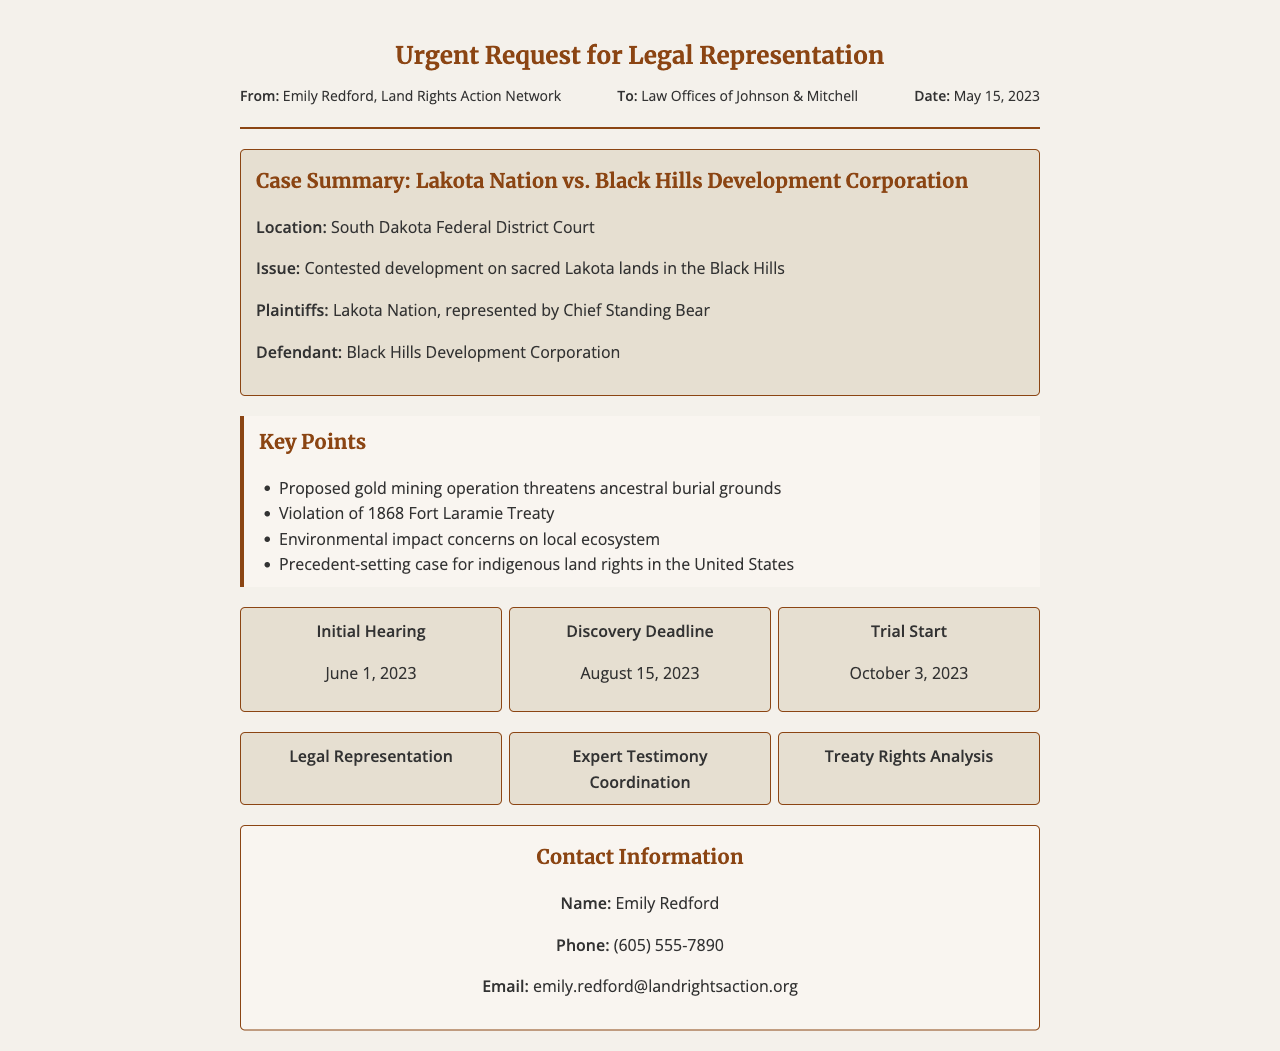what is the case title? The case title is mentioned prominently in the case summary section of the document.
Answer: Lakota Nation vs. Black Hills Development Corporation who is the plaintiff in the case? The plaintiffs of the case are identified in the case summary section, highlighting who is bringing the case to court.
Answer: Lakota Nation what date is the trial scheduled to start? The trial start date is included in the court dates section, providing a specific timeline for the proceedings.
Answer: October 3, 2023 what is the main issue being contested in the case? The main issue is provided in the case summary, explaining the reason behind the legal action.
Answer: Contested development on sacred Lakota lands in the Black Hills what is one key concern raised in the case? Key concerns are listed in the key points section, detailing the issues at stake for the plaintiffs.
Answer: Proposed gold mining operation threatens ancestral burial grounds who is the contact person for this fax? Contact information is provided at the end of the document, identifying the primary individual for inquiries.
Answer: Emily Redford when is the discovery deadline? The discovery deadline is specified in the court dates section, marking an important date in the legal process.
Answer: August 15, 2023 what type of representation is being requested? The type of representation requested is indicated in the request details section, outlining the legal needs.
Answer: Legal Representation what court is the case being heard in? The court location is mentioned in the case summary, identifying where the case is taking place.
Answer: South Dakota Federal District Court 